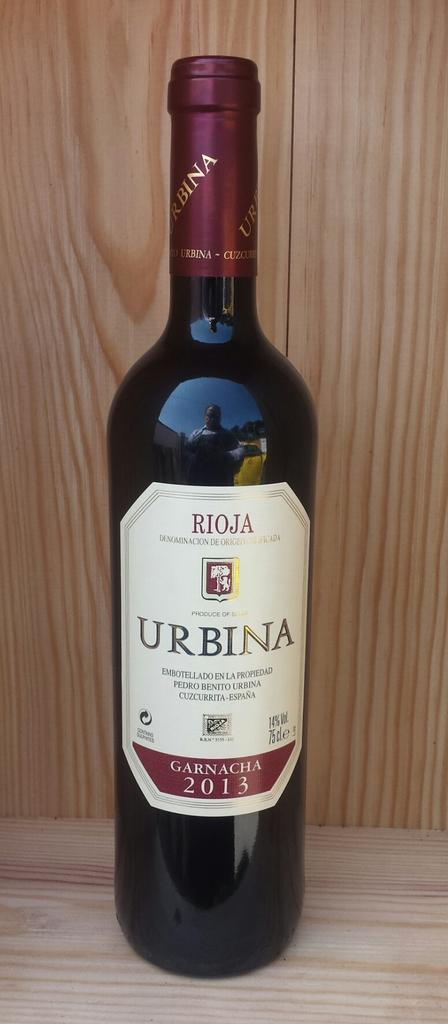<image>
Write a terse but informative summary of the picture. Black bottle with a white label taht says the year 2013 near the bottom. 